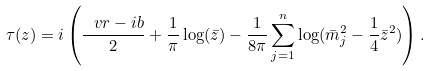Convert formula to latex. <formula><loc_0><loc_0><loc_500><loc_500>\tau ( z ) = i \left ( \frac { \ v r - i b } { 2 } + \frac { 1 } { \pi } \log ( \bar { z } ) - \frac { 1 } { 8 \pi } \sum _ { j = 1 } ^ { n } \log ( \bar { m } _ { j } ^ { 2 } - \frac { 1 } { 4 } \bar { z } ^ { 2 } ) \right ) .</formula> 